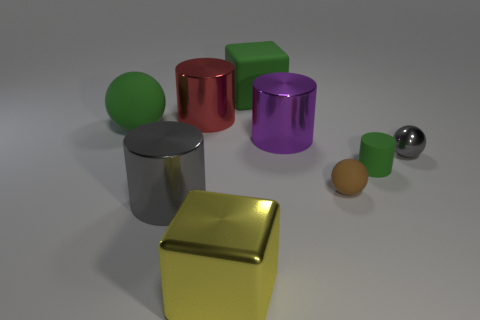Subtract all gray cylinders. How many cylinders are left? 3 Add 1 tiny brown matte spheres. How many objects exist? 10 Subtract all purple cylinders. How many cylinders are left? 3 Add 6 green rubber cylinders. How many green rubber cylinders exist? 7 Subtract 1 green cylinders. How many objects are left? 8 Subtract all cubes. How many objects are left? 7 Subtract 1 cubes. How many cubes are left? 1 Subtract all gray spheres. Subtract all purple cylinders. How many spheres are left? 2 Subtract all brown cylinders. How many green cubes are left? 1 Subtract all red objects. Subtract all brown rubber balls. How many objects are left? 7 